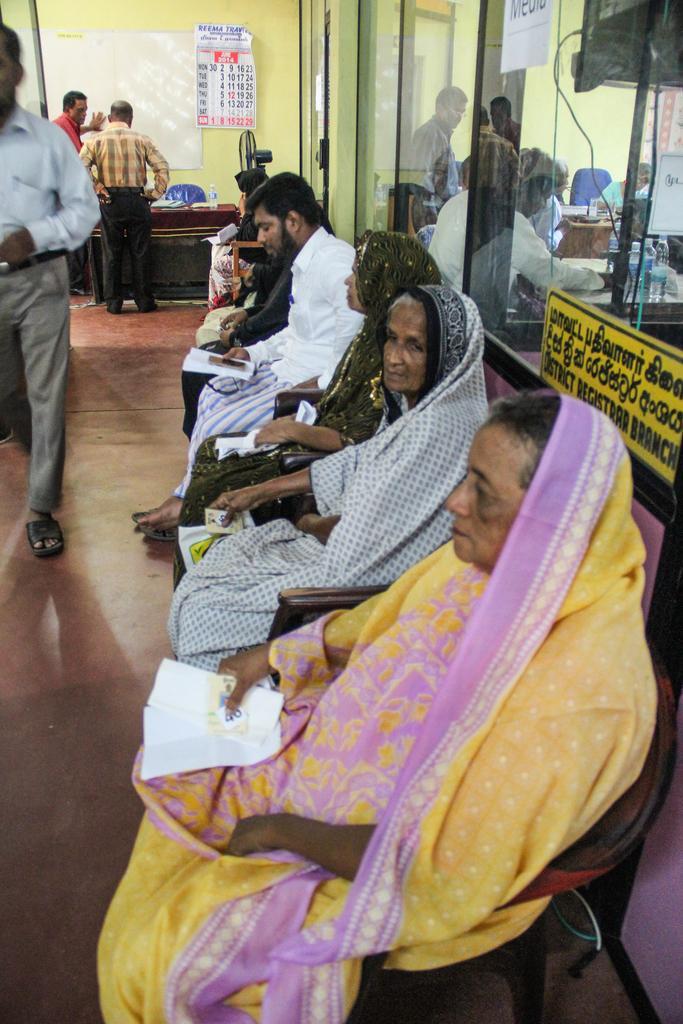Describe this image in one or two sentences. In this image we can see a group of people sitting on chairs. One person is holding a paper in his hand. To the left side of the image we can see some persons standing. On the right side of the image we can see some persons, bottle placed on the table, a board with some text on it. In the background, we can see a chair, board and a calendar on the wall. 